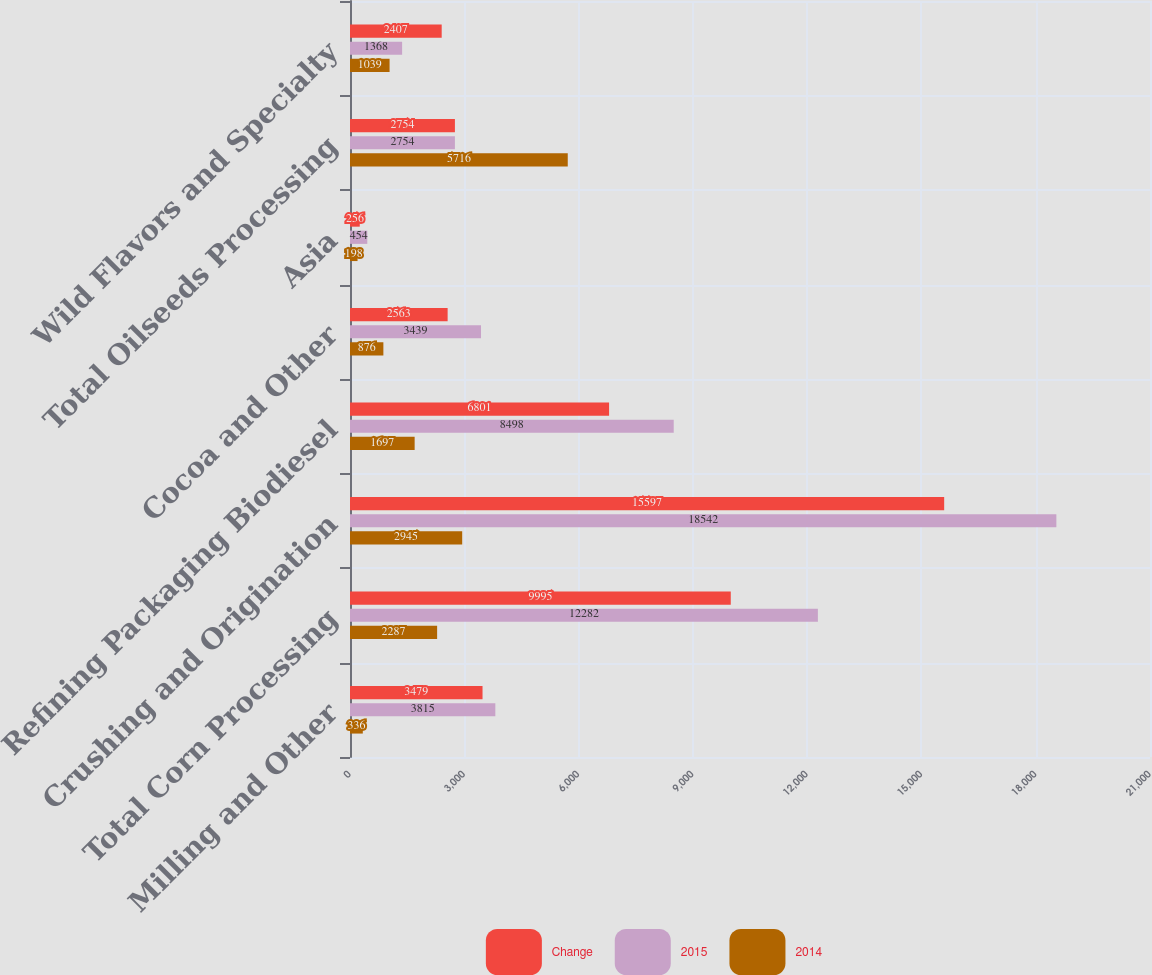<chart> <loc_0><loc_0><loc_500><loc_500><stacked_bar_chart><ecel><fcel>Milling and Other<fcel>Total Corn Processing<fcel>Crushing and Origination<fcel>Refining Packaging Biodiesel<fcel>Cocoa and Other<fcel>Asia<fcel>Total Oilseeds Processing<fcel>Wild Flavors and Specialty<nl><fcel>Change<fcel>3479<fcel>9995<fcel>15597<fcel>6801<fcel>2563<fcel>256<fcel>2754<fcel>2407<nl><fcel>2015<fcel>3815<fcel>12282<fcel>18542<fcel>8498<fcel>3439<fcel>454<fcel>2754<fcel>1368<nl><fcel>2014<fcel>336<fcel>2287<fcel>2945<fcel>1697<fcel>876<fcel>198<fcel>5716<fcel>1039<nl></chart> 